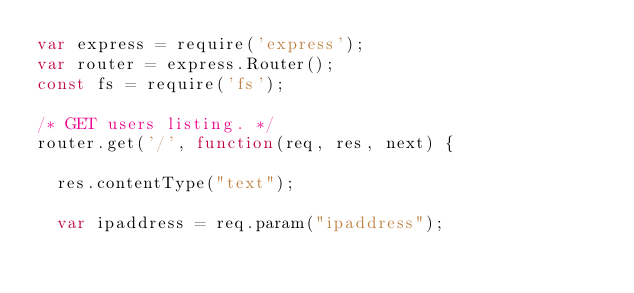Convert code to text. <code><loc_0><loc_0><loc_500><loc_500><_JavaScript_>var express = require('express');
var router = express.Router();
const fs = require('fs');

/* GET users listing. */
router.get('/', function(req, res, next) {

  res.contentType("text");

  var ipaddress = req.param("ipaddress");
</code> 